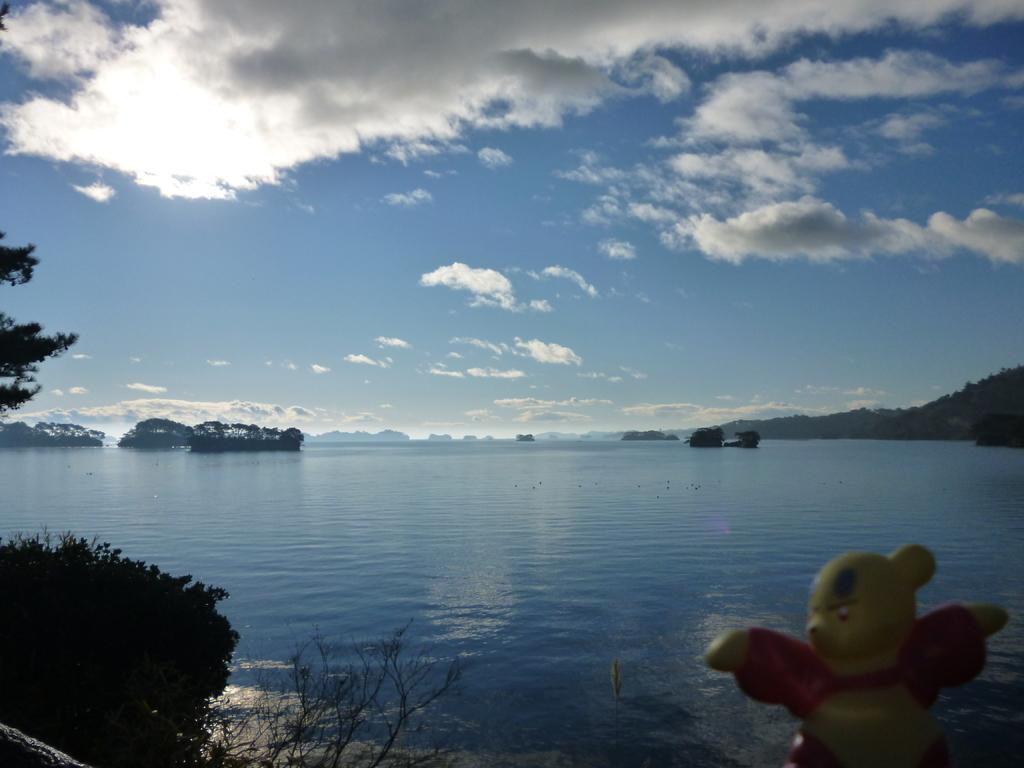What is the primary element visible in the image? There is water in the image. What object can be found at the bottom of the image? There is a toy at the bottom of the image. What type of vegetation is present in the image? There are many trees in the image. What can be seen in the background of the image? The sky with clouds is visible in the background of the image. What arithmetic problem is the grandmother solving in the image? There is no grandmother or arithmetic problem present in the image. 